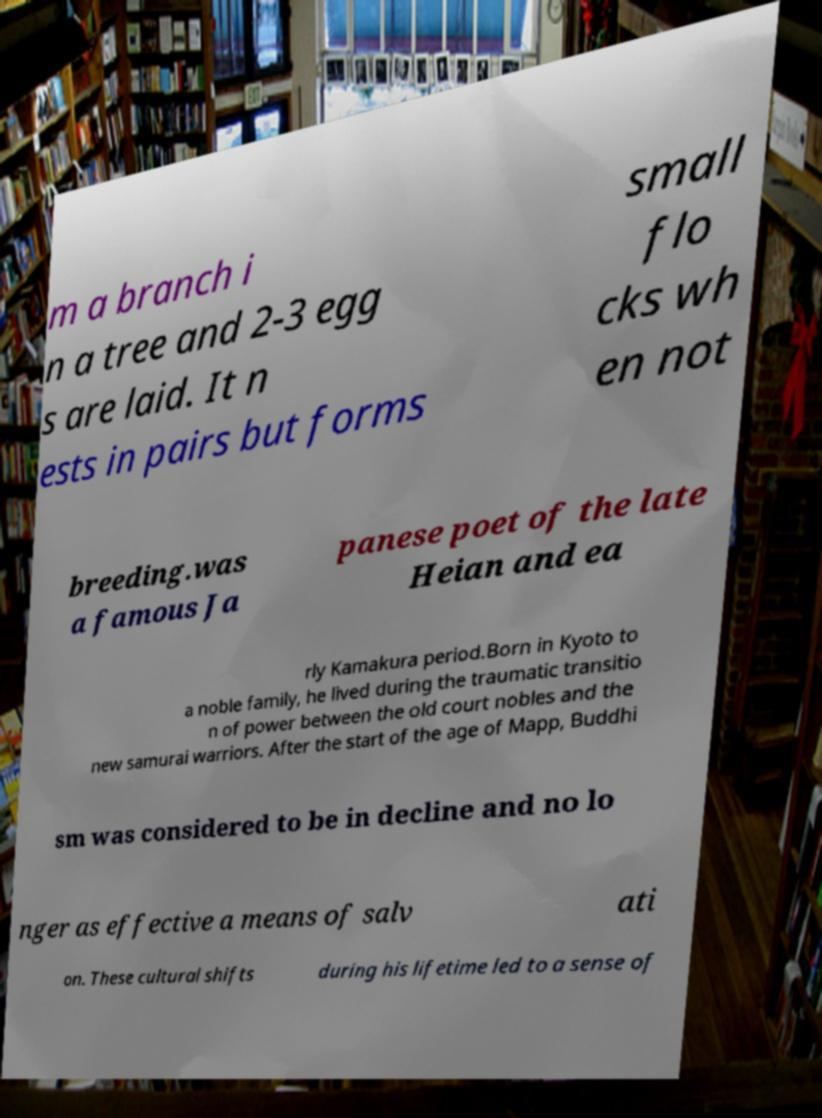I need the written content from this picture converted into text. Can you do that? m a branch i n a tree and 2-3 egg s are laid. It n ests in pairs but forms small flo cks wh en not breeding.was a famous Ja panese poet of the late Heian and ea rly Kamakura period.Born in Kyoto to a noble family, he lived during the traumatic transitio n of power between the old court nobles and the new samurai warriors. After the start of the age of Mapp, Buddhi sm was considered to be in decline and no lo nger as effective a means of salv ati on. These cultural shifts during his lifetime led to a sense of 